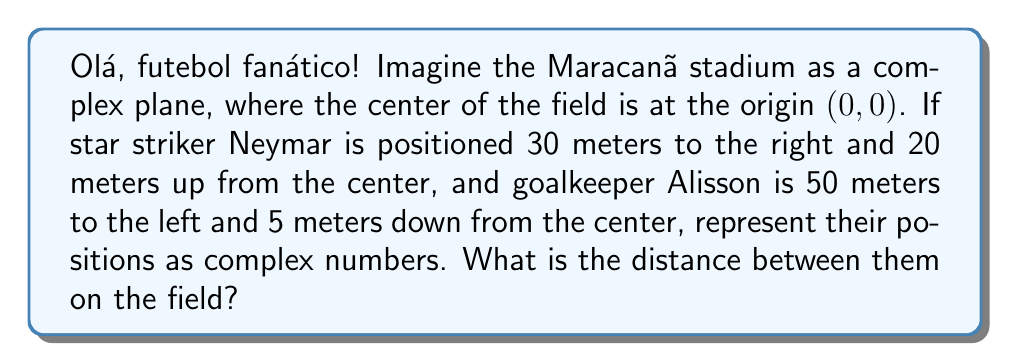Provide a solution to this math problem. Let's approach this step-by-step:

1) First, we need to represent the players' positions as complex numbers:

   Neymar: 30 meters right and 20 meters up
   $z_1 = 30 + 20i$

   Alisson: 50 meters left and 5 meters down
   $z_2 = -50 - 5i$

2) To find the distance between them, we can use the distance formula for complex numbers:

   $d = |z_1 - z_2|$

3) Let's calculate $z_1 - z_2$:
   
   $z_1 - z_2 = (30 + 20i) - (-50 - 5i)$
   $= 30 + 20i + 50 + 5i$
   $= 80 + 25i$

4) Now, we need to find the absolute value (magnitude) of this complex number:

   $|80 + 25i| = \sqrt{80^2 + 25^2}$

5) Let's calculate:

   $\sqrt{80^2 + 25^2} = \sqrt{6400 + 625} = \sqrt{7025} = 83.8$

Therefore, the distance between Neymar and Alisson is approximately 83.8 meters.
Answer: $83.8$ meters 